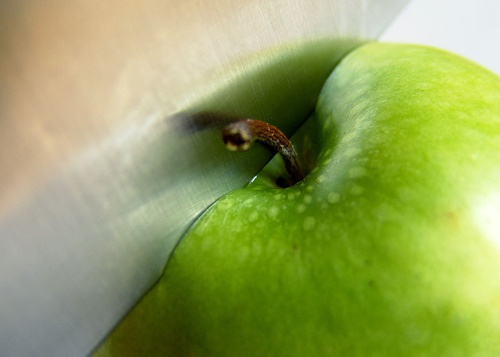Describe the objects in this image and their specific colors. I can see apple in gray, olive, darkgreen, khaki, and black tones and knife in tan and darkgray tones in this image. 